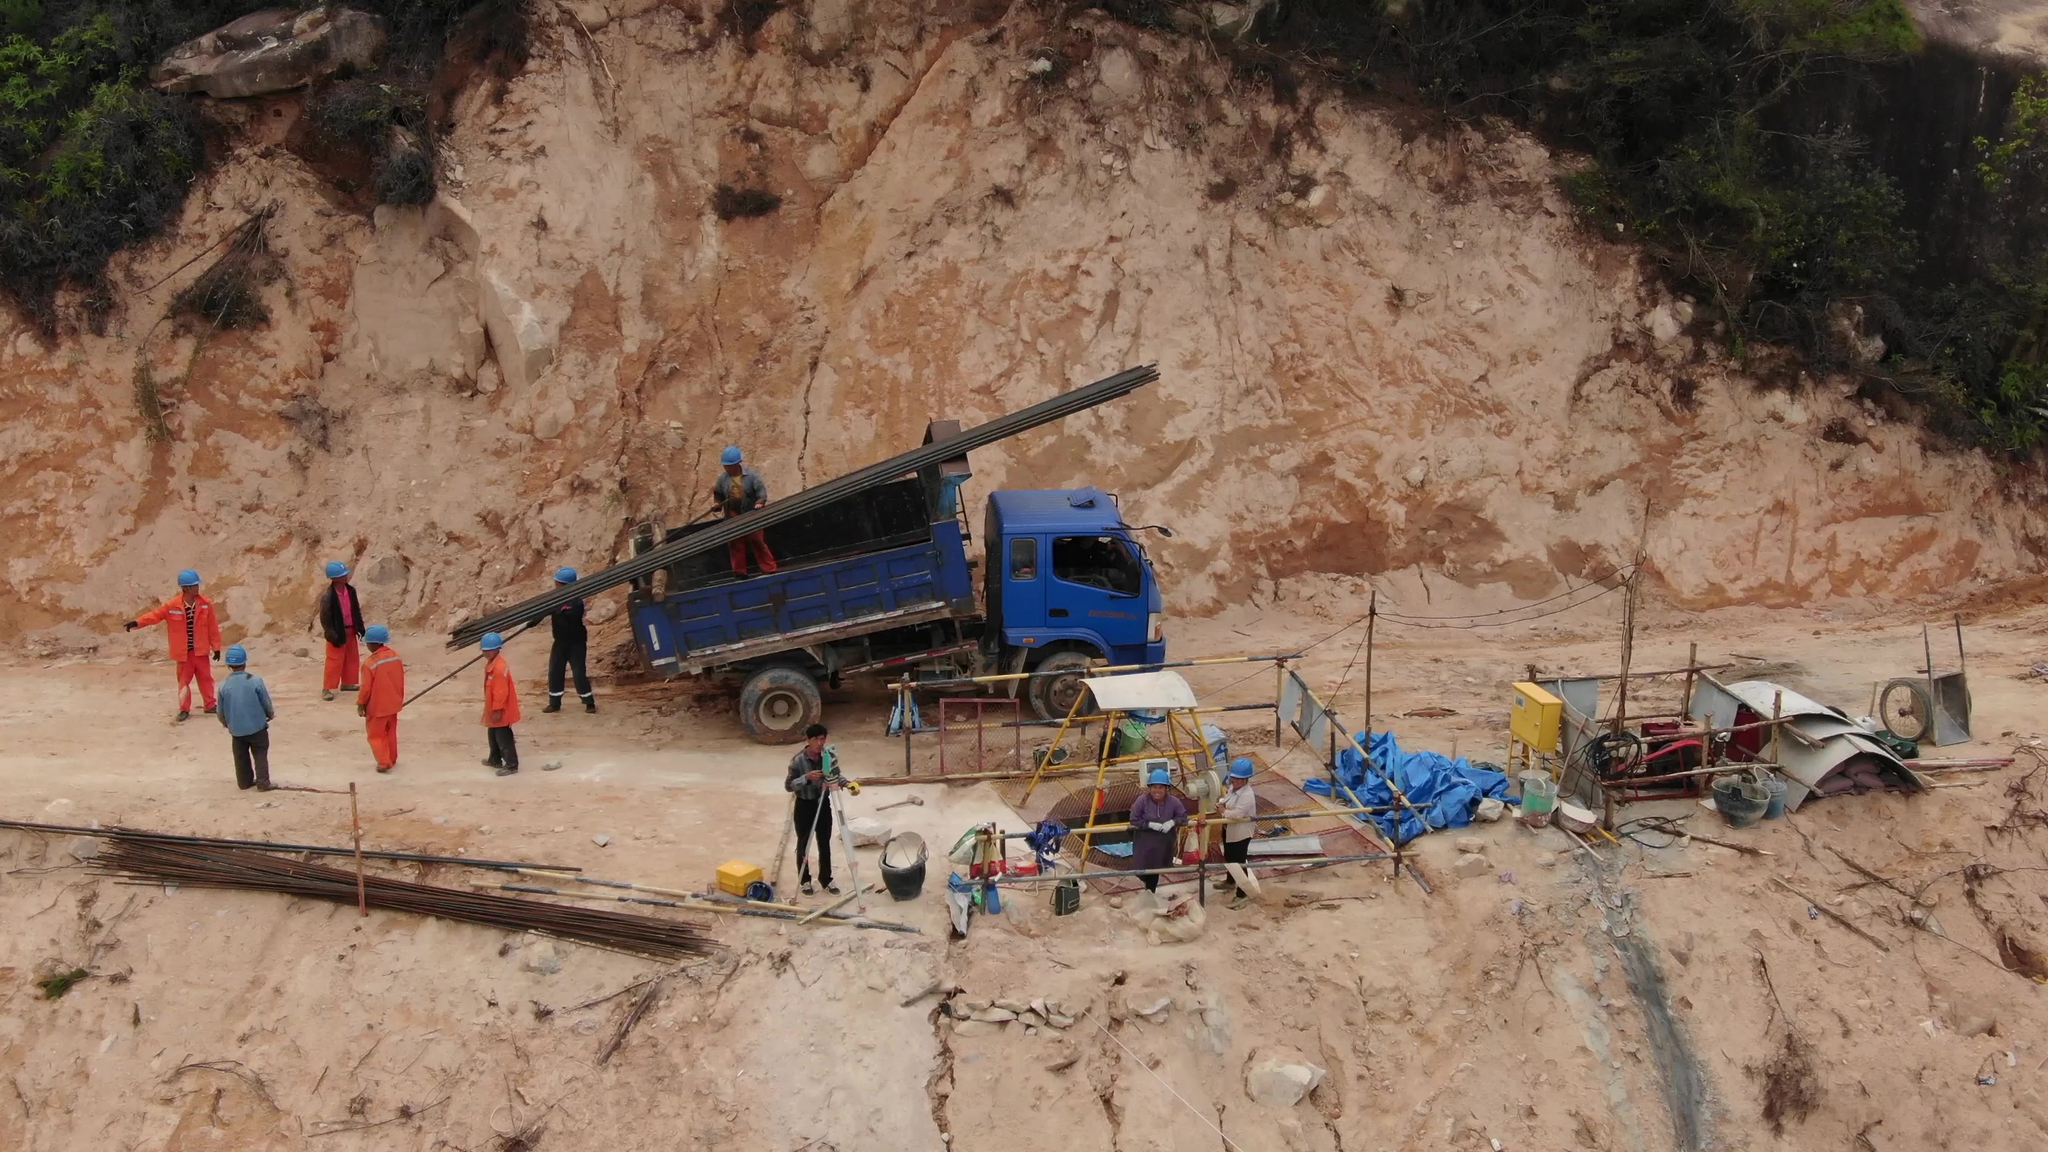It is illegal to have people standing under the crane arm. Is there any illegal behavior in this picture? Yes, there is illegal behavior in this picture. There are people standing under the crane arm, which is a safety violation. It is unsafe and against regulations to have individuals positioned under the crane arm due to the risk of falling objects or crane malfunction. The area under the crane arm should be kept clear to ensure the safety of all workers on the site. Frame the person in the picture without a helmet Here is the framed person in the picture without a helmet:

![Person without helmet](https://i.imgur.com/6l0l13l.jpg)

This individual should be wearing a helmet to comply with safety regulations on the construction site. 